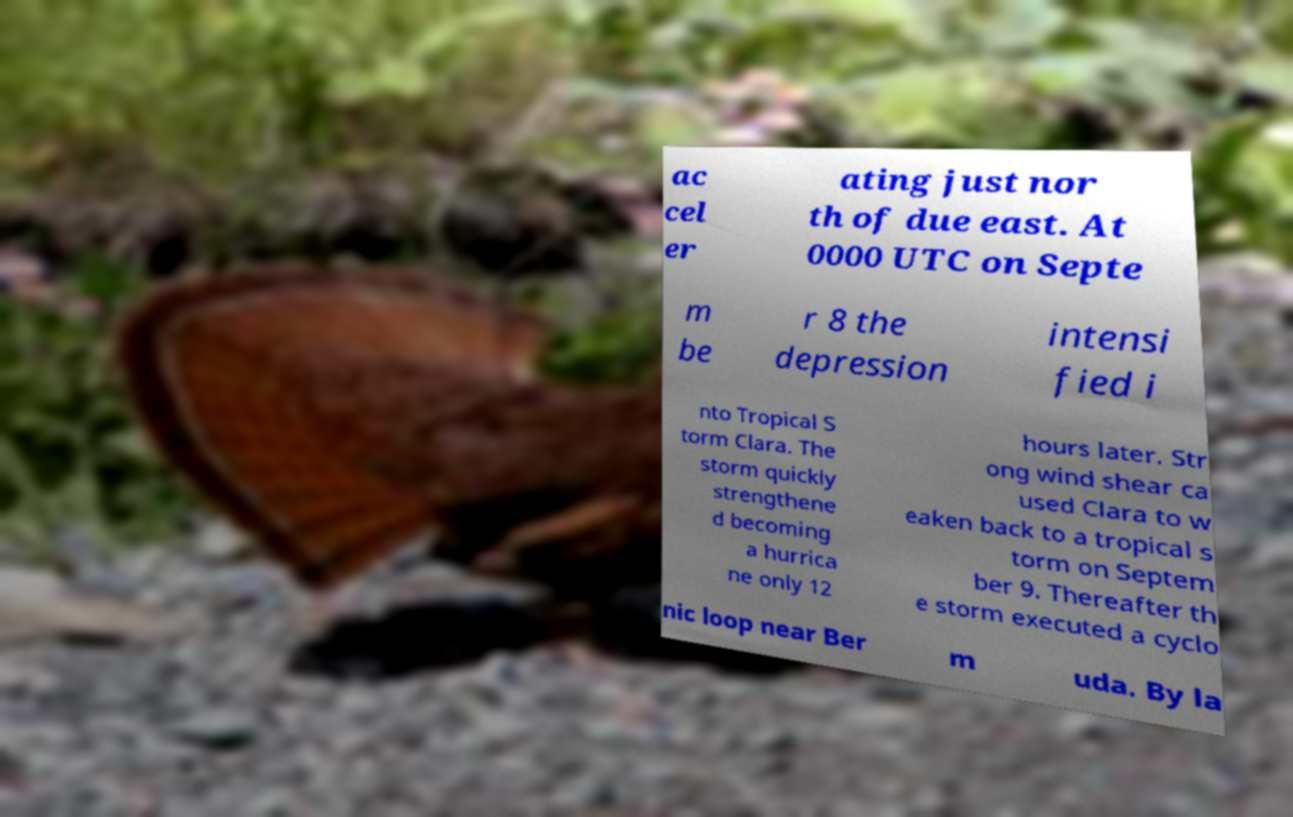Could you extract and type out the text from this image? ac cel er ating just nor th of due east. At 0000 UTC on Septe m be r 8 the depression intensi fied i nto Tropical S torm Clara. The storm quickly strengthene d becoming a hurrica ne only 12 hours later. Str ong wind shear ca used Clara to w eaken back to a tropical s torm on Septem ber 9. Thereafter th e storm executed a cyclo nic loop near Ber m uda. By la 